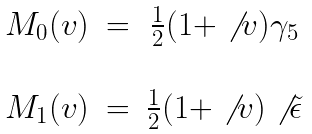<formula> <loc_0><loc_0><loc_500><loc_500>\begin{array} { c c c } M _ { 0 } ( v ) & = & \frac { 1 } { 2 } ( 1 + \not { \, v } ) \gamma _ { 5 } \\ \\ M _ { 1 } ( v ) & = & \frac { 1 } { 2 } ( 1 + \not { \, v } ) \not { \, \tilde { \epsilon } } \end{array}</formula> 